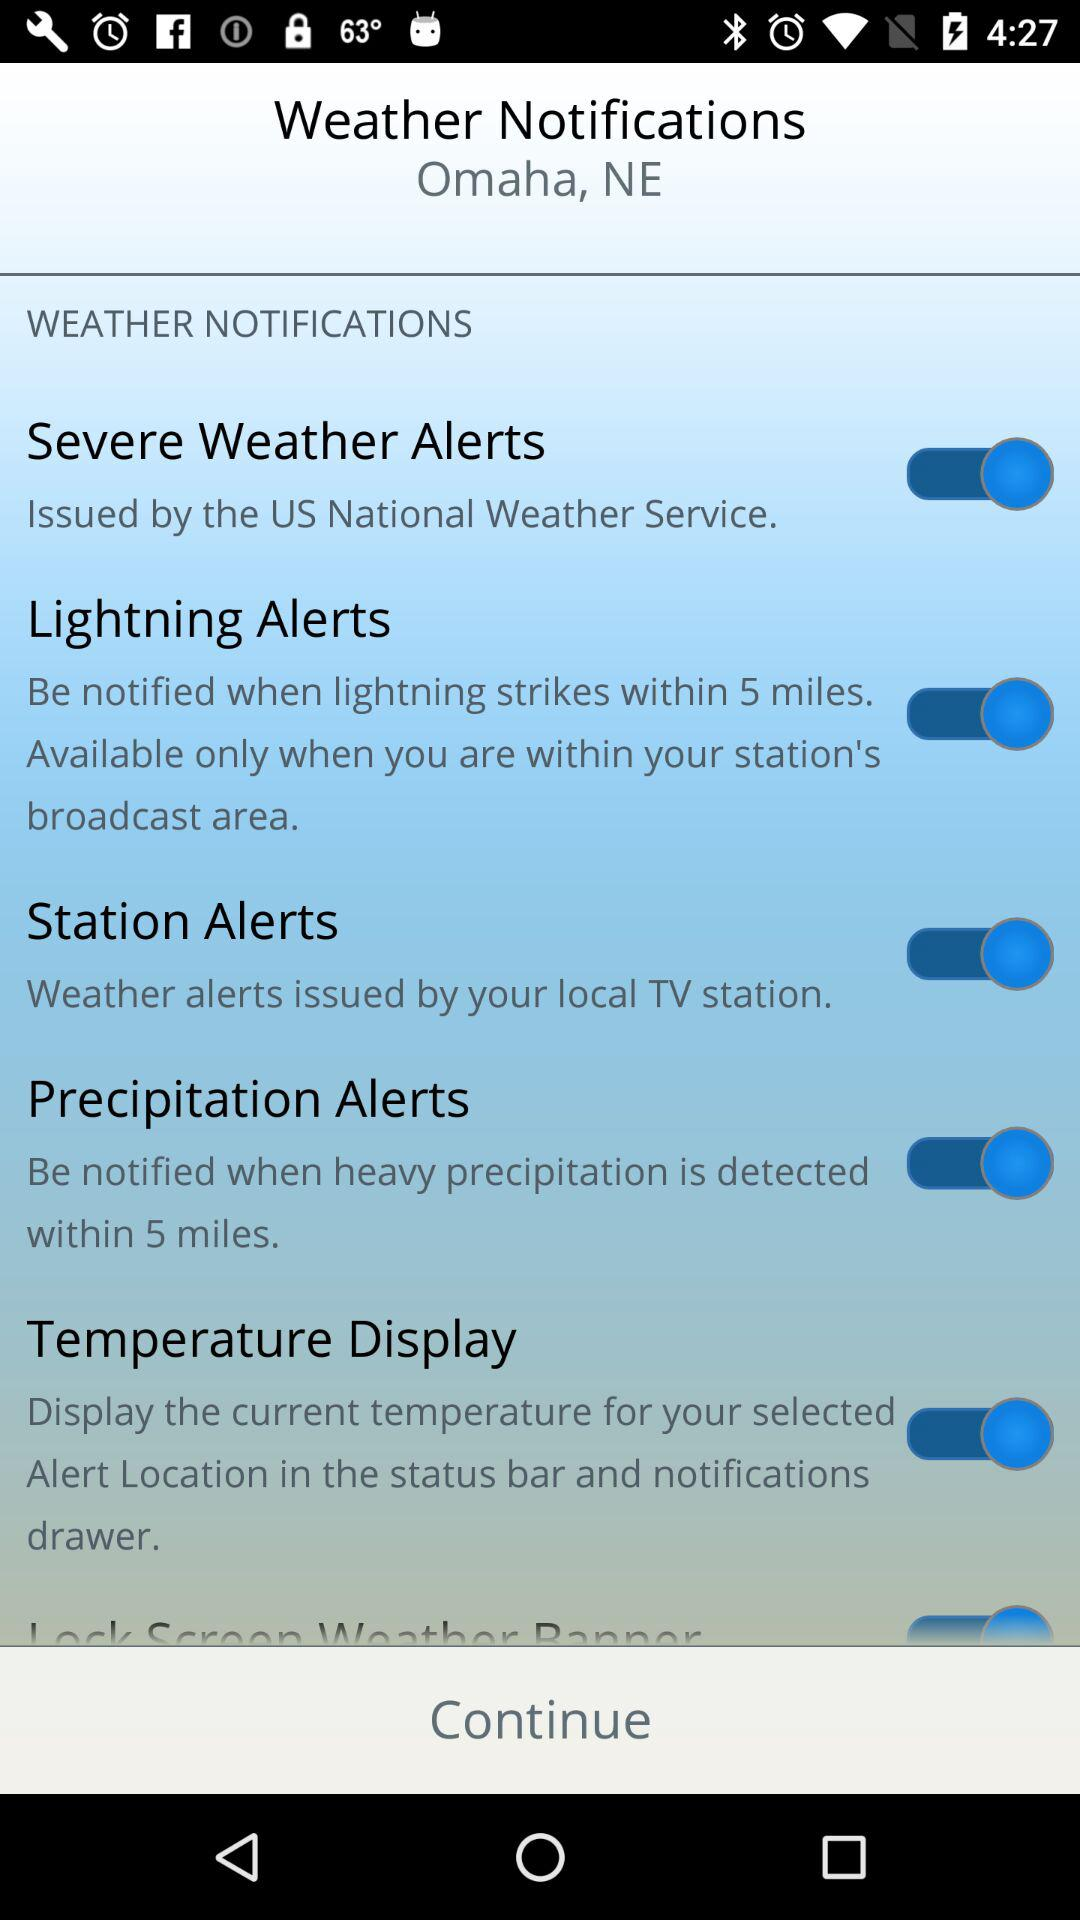What is the location? The location is Omaha, NE. 